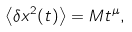<formula> <loc_0><loc_0><loc_500><loc_500>\left \langle \delta x ^ { 2 } ( t ) \right \rangle = M t ^ { \mu } ,</formula> 